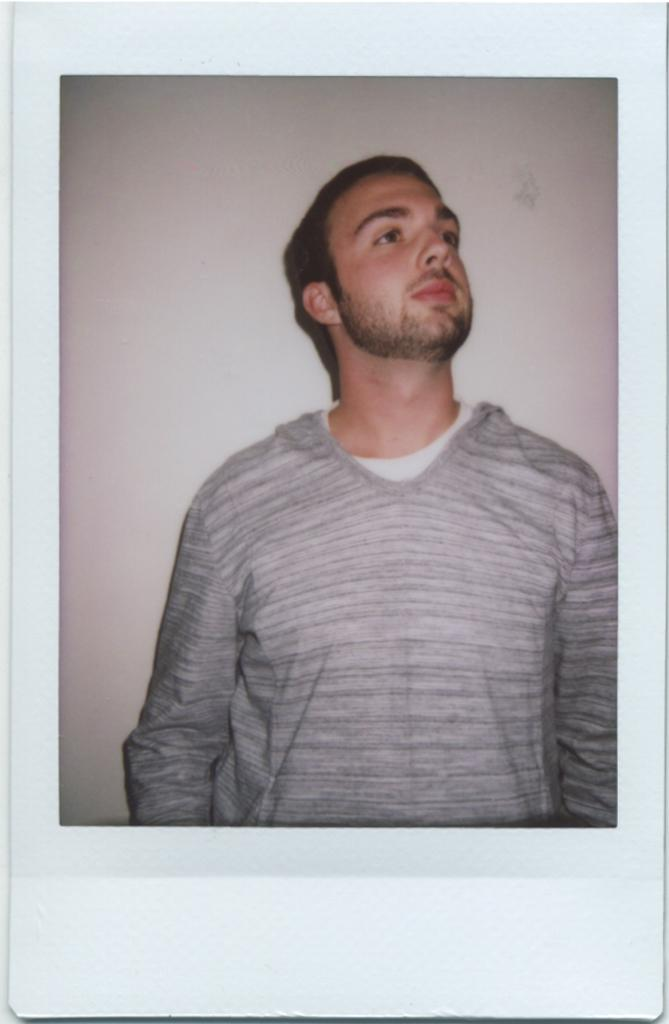What is the main subject of the image? The main subject of the image is a photograph of a person. What type of fire can be seen in the background of the image? There is no fire present in the image; it features a photograph of a person. What type of authority figure is depicted in the image? There is no authority figure depicted in the image; it features a photograph of a person. What is the position of the moon in the image? There is no moon present in the image; it features a photograph of a person. 